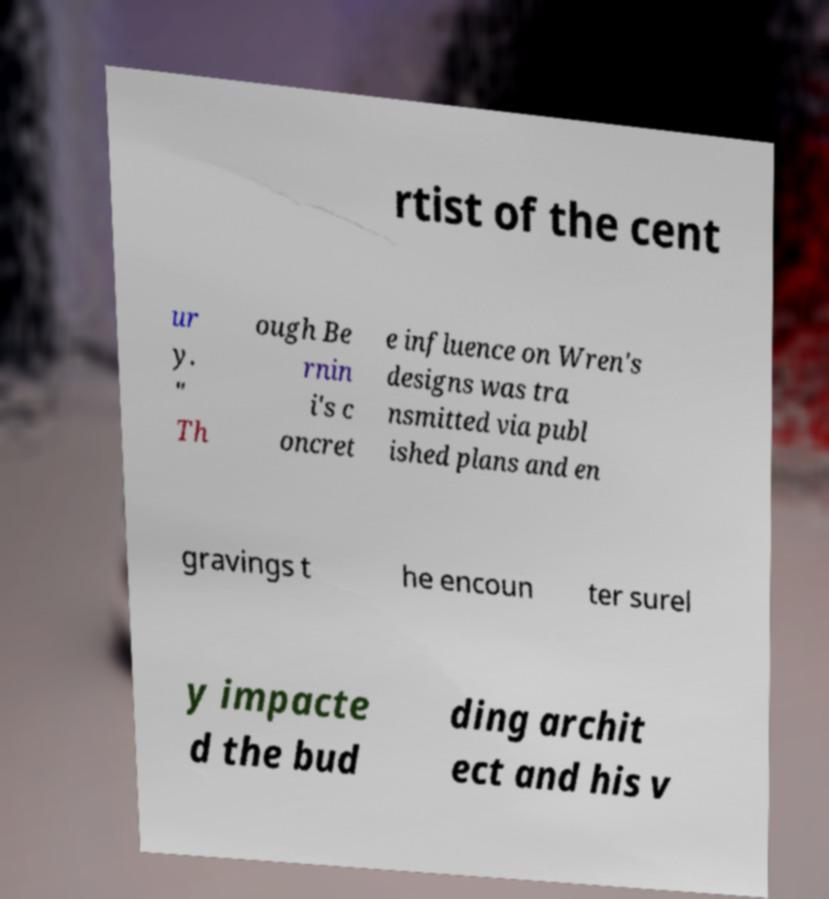Can you read and provide the text displayed in the image?This photo seems to have some interesting text. Can you extract and type it out for me? rtist of the cent ur y. " Th ough Be rnin i's c oncret e influence on Wren's designs was tra nsmitted via publ ished plans and en gravings t he encoun ter surel y impacte d the bud ding archit ect and his v 